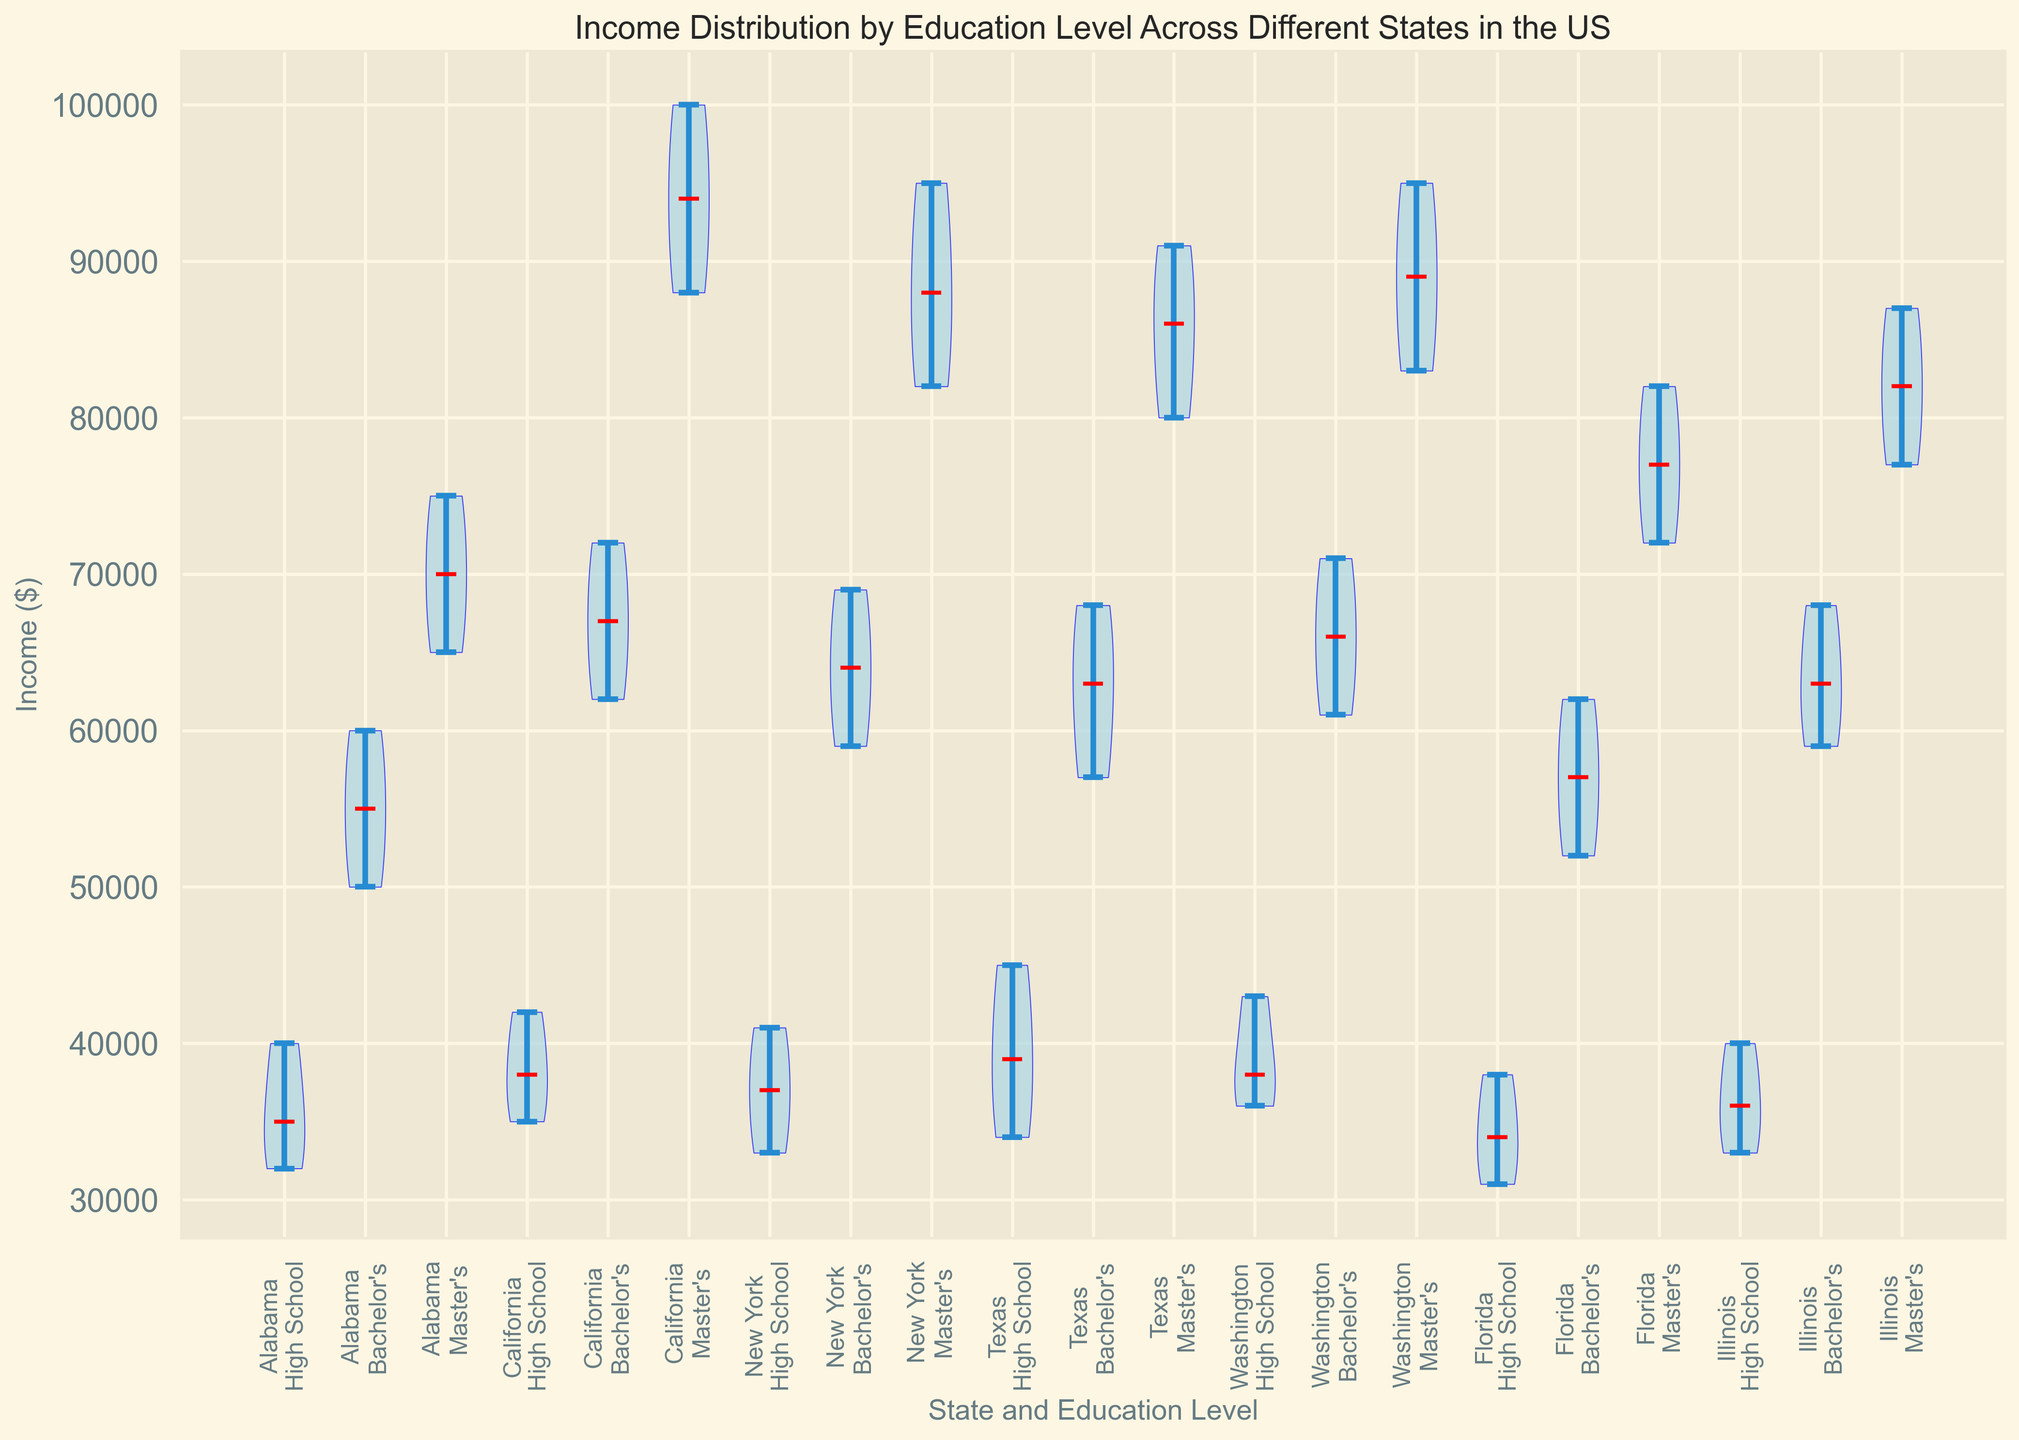What's the median income for individuals with a Bachelor's degree in California? Locate the section of the violin plot representing California's Bachelor's degree. The red line within the violin plot indicates the median income value.
Answer: 67,000 Which state shows the widest range of income for individuals with a Master's degree? Identify the violin plot sections representing Master's degrees and observe their spread. California's Master's degree shows the widest range, from around 88,000 to 100,000.
Answer: California Compare the median incomes for individuals with a High School education in Alabama and Texas. Which state has a higher median income? Locate sections for High School in Alabama and Texas. Compare the red median lines. Texas shows a higher median income.
Answer: Texas What is the median income difference between Bachelor's degree holders in New York and Illinois? Find the Bachelor’s degree sections for New York and Illinois; compare the median values shown by the red lines. New York's median is 64,000 and Illinois's is 63,000.
Answer: 1,000 How does the income distribution for Master's degree holders in Florida compare to those in New York? Focus on the spread and median lines of the violins for Florida and New York, Master's degree sections. New York has a higher median and a wider spread.
Answer: New York has higher and wider distribution Among High School graduates, which state has the lowest median income? Look at all High School sections and compare their median lines. Florida's High School income has the lowest median.
Answer: Florida In which state do Master's degree holders have the closest median to 80,000? Check the red median lines for Master's degree sections in all states, find the one closest to 80,000. Florida shows the closest median to 80,000.
Answer: Florida Which state and education level pair shows the highest median income in the entire plot? Review all state and education level sections for the red median lines. California's Master's degree section shows the highest median income.
Answer: California Master's degree How do the ranges of income for Bachelor's degree holders in Texas and Washington compare? Observe the spread of the violin plots for Bachelor's degree in Texas and Washington; compare their ranges from lowest to highest values. Washington has a broader range compared to Texas.
Answer: Washington 